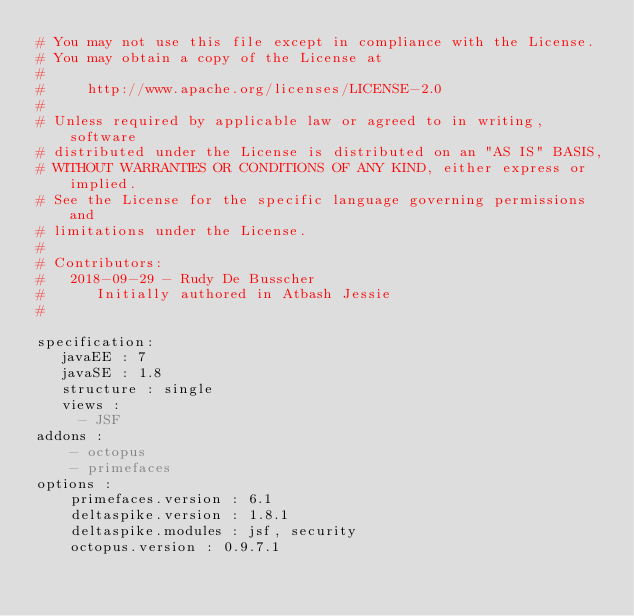Convert code to text. <code><loc_0><loc_0><loc_500><loc_500><_YAML_># You may not use this file except in compliance with the License.
# You may obtain a copy of the License at
#
#     http://www.apache.org/licenses/LICENSE-2.0
#
# Unless required by applicable law or agreed to in writing, software
# distributed under the License is distributed on an "AS IS" BASIS,
# WITHOUT WARRANTIES OR CONDITIONS OF ANY KIND, either express or implied.
# See the License for the specific language governing permissions and
# limitations under the License.
#
# Contributors:
#   2018-09-29 - Rudy De Busscher
#      Initially authored in Atbash Jessie
#

specification:
   javaEE : 7
   javaSE : 1.8
   structure : single
   views :
     - JSF
addons :
    - octopus
    - primefaces
options :
    primefaces.version : 6.1
    deltaspike.version : 1.8.1
    deltaspike.modules : jsf, security
    octopus.version : 0.9.7.1</code> 